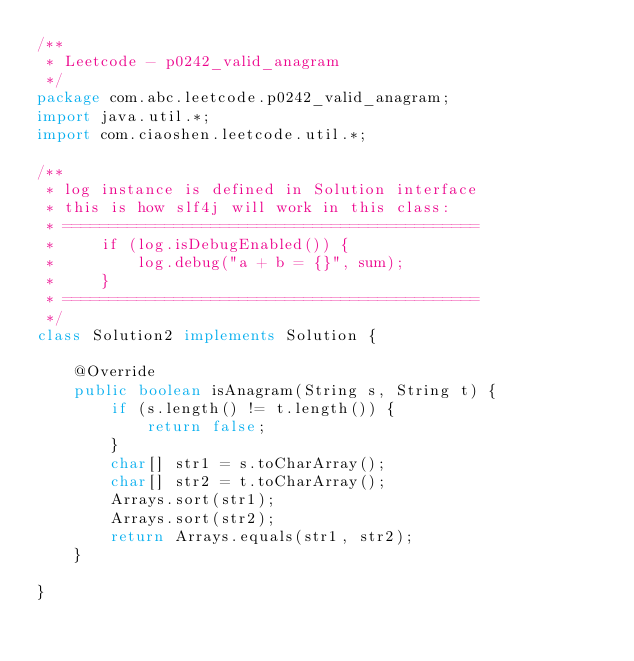Convert code to text. <code><loc_0><loc_0><loc_500><loc_500><_Java_>/**
 * Leetcode - p0242_valid_anagram
 */
package com.abc.leetcode.p0242_valid_anagram;
import java.util.*;
import com.ciaoshen.leetcode.util.*;

/** 
 * log instance is defined in Solution interface
 * this is how slf4j will work in this class:
 * =============================================
 *     if (log.isDebugEnabled()) {
 *         log.debug("a + b = {}", sum);
 *     }
 * =============================================
 */
class Solution2 implements Solution {

    @Override
    public boolean isAnagram(String s, String t) {
        if (s.length() != t.length()) {
            return false;
        }
        char[] str1 = s.toCharArray();
        char[] str2 = t.toCharArray();
        Arrays.sort(str1);
        Arrays.sort(str2);
        return Arrays.equals(str1, str2);
    }

}
</code> 